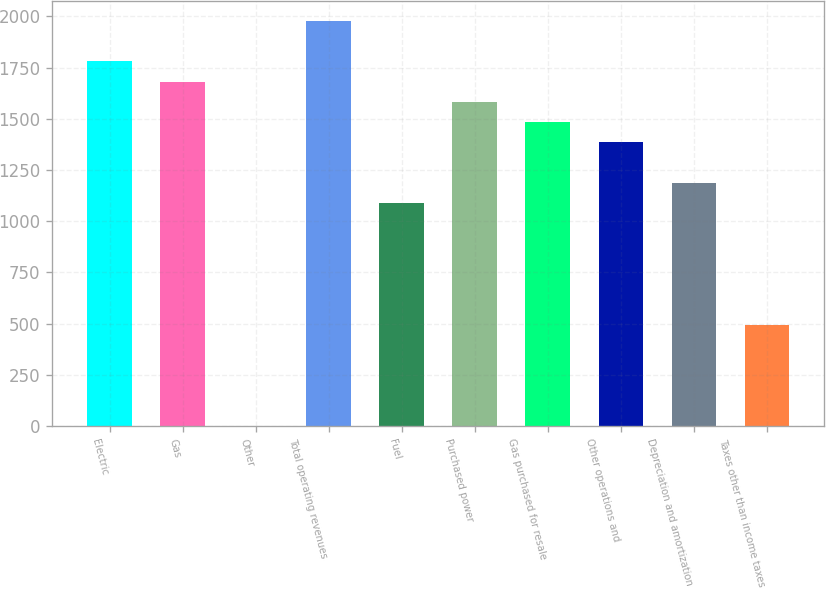<chart> <loc_0><loc_0><loc_500><loc_500><bar_chart><fcel>Electric<fcel>Gas<fcel>Other<fcel>Total operating revenues<fcel>Fuel<fcel>Purchased power<fcel>Gas purchased for resale<fcel>Other operations and<fcel>Depreciation and amortization<fcel>Taxes other than income taxes<nl><fcel>1781.2<fcel>1682.3<fcel>1<fcel>1979<fcel>1088.9<fcel>1583.4<fcel>1484.5<fcel>1385.6<fcel>1187.8<fcel>495.5<nl></chart> 